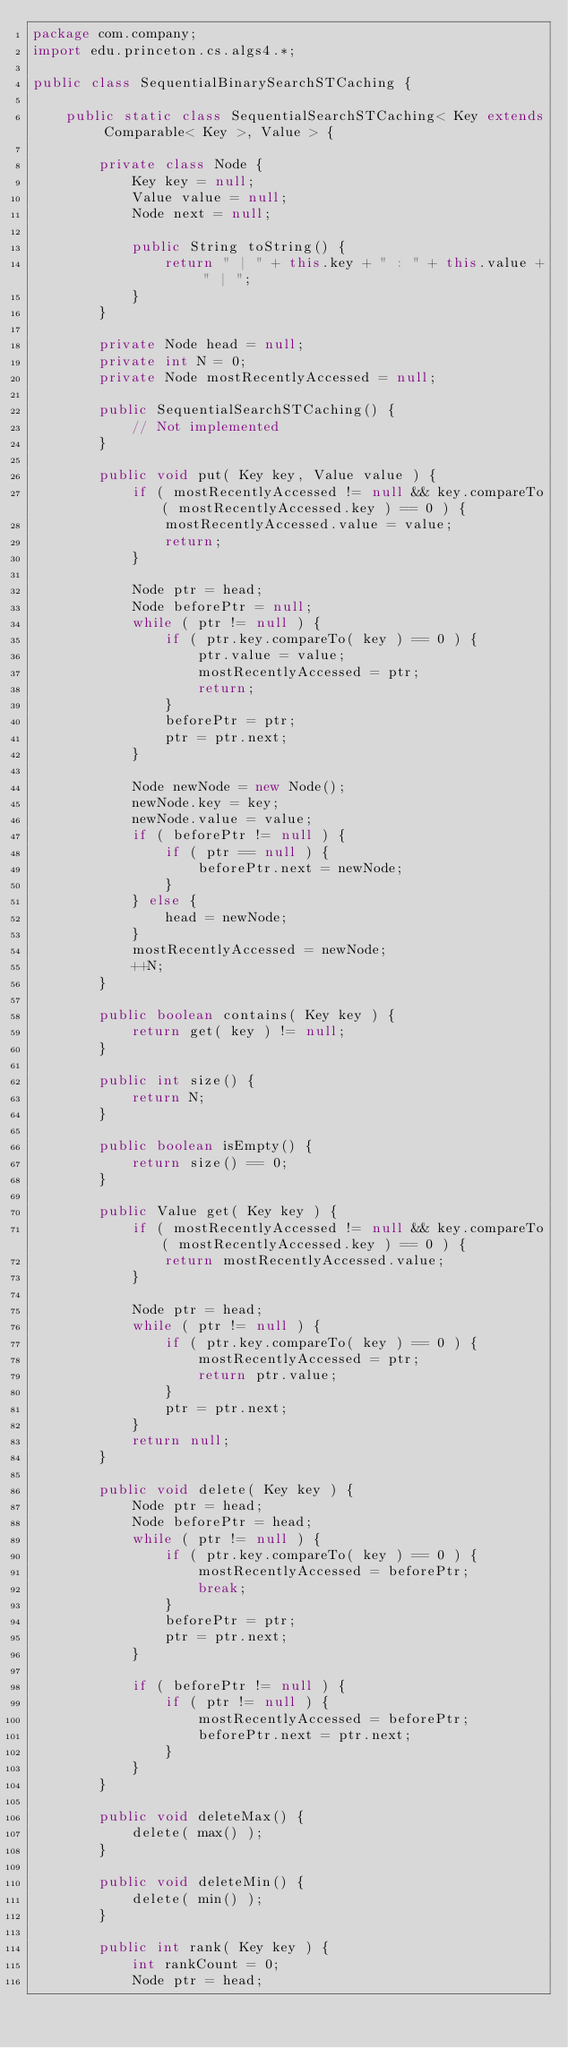<code> <loc_0><loc_0><loc_500><loc_500><_Java_>package com.company;
import edu.princeton.cs.algs4.*;

public class SequentialBinarySearchSTCaching {

    public static class SequentialSearchSTCaching< Key extends Comparable< Key >, Value > {

        private class Node {
            Key key = null;
            Value value = null;
            Node next = null;

            public String toString() {
                return " | " + this.key + " : " + this.value + " | ";
            }
        }

        private Node head = null;
        private int N = 0;
        private Node mostRecentlyAccessed = null;

        public SequentialSearchSTCaching() {
            // Not implemented
        }

        public void put( Key key, Value value ) {
            if ( mostRecentlyAccessed != null && key.compareTo( mostRecentlyAccessed.key ) == 0 ) {
                mostRecentlyAccessed.value = value;
                return;
            }

            Node ptr = head;
            Node beforePtr = null;
            while ( ptr != null ) {
                if ( ptr.key.compareTo( key ) == 0 ) {
                    ptr.value = value;
                    mostRecentlyAccessed = ptr;
                    return;
                }
                beforePtr = ptr;
                ptr = ptr.next;
            }

            Node newNode = new Node();
            newNode.key = key;
            newNode.value = value;
            if ( beforePtr != null ) {
                if ( ptr == null ) {
                    beforePtr.next = newNode;
                }
            } else {
                head = newNode;
            }
            mostRecentlyAccessed = newNode;
            ++N;
        }

        public boolean contains( Key key ) {
            return get( key ) != null;
        }

        public int size() {
            return N;
        }

        public boolean isEmpty() {
            return size() == 0;
        }

        public Value get( Key key ) {
            if ( mostRecentlyAccessed != null && key.compareTo( mostRecentlyAccessed.key ) == 0 ) {
                return mostRecentlyAccessed.value;
            }

            Node ptr = head;
            while ( ptr != null ) {
                if ( ptr.key.compareTo( key ) == 0 ) {
                    mostRecentlyAccessed = ptr;
                    return ptr.value;
                }
                ptr = ptr.next;
            }
            return null;
        }

        public void delete( Key key ) {
            Node ptr = head;
            Node beforePtr = head;
            while ( ptr != null ) {
                if ( ptr.key.compareTo( key ) == 0 ) {
                    mostRecentlyAccessed = beforePtr;
                    break;
                }
                beforePtr = ptr;
                ptr = ptr.next;
            }

            if ( beforePtr != null ) {
                if ( ptr != null ) {
                    mostRecentlyAccessed = beforePtr;
                    beforePtr.next = ptr.next;
                }
            }
        }

        public void deleteMax() {
            delete( max() );
        }

        public void deleteMin() {
            delete( min() );
        }

        public int rank( Key key ) {
            int rankCount = 0;
            Node ptr = head;</code> 